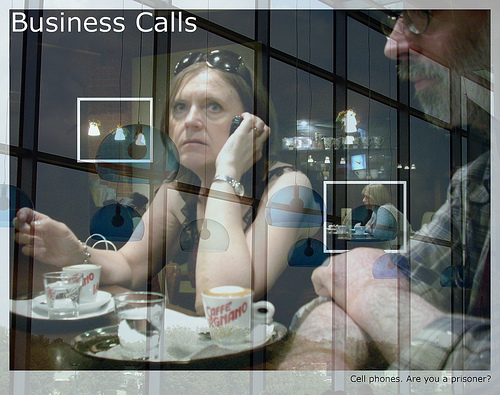Is the coffee cup sitting on top of the plate? Yes, the coffee cup is indeed on top of the plate. 